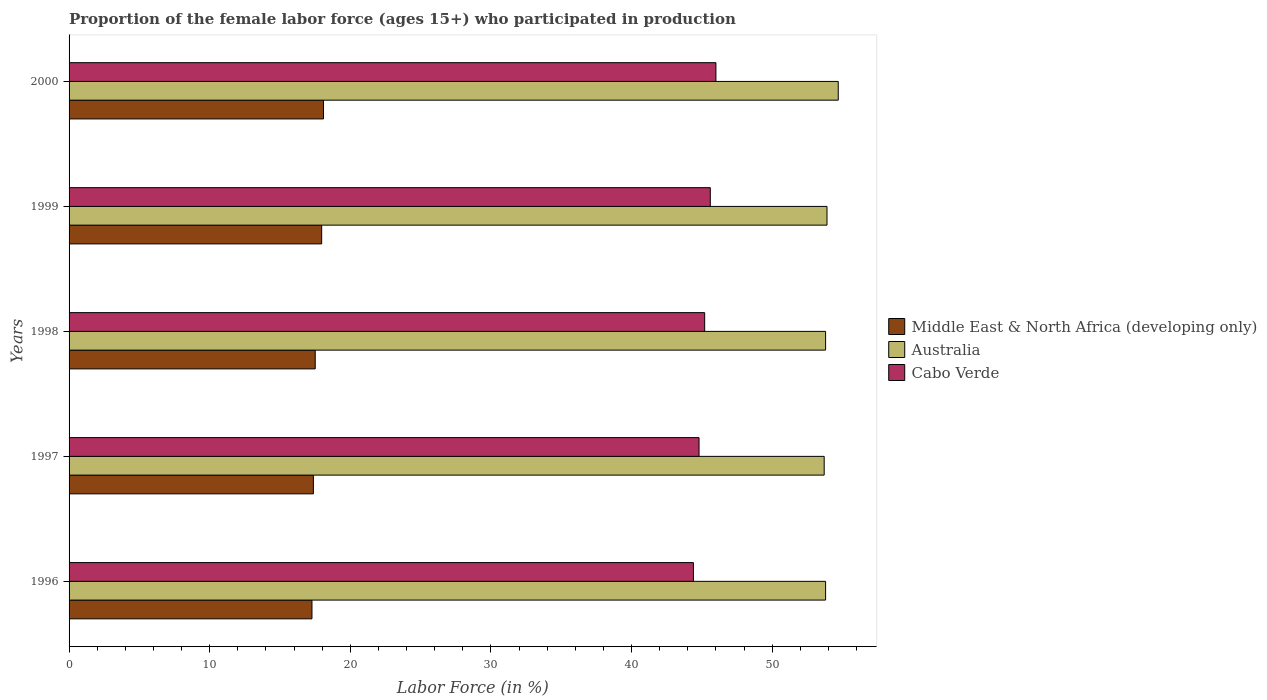How many different coloured bars are there?
Make the answer very short. 3. How many groups of bars are there?
Offer a very short reply. 5. Are the number of bars per tick equal to the number of legend labels?
Provide a succinct answer. Yes. Are the number of bars on each tick of the Y-axis equal?
Your answer should be compact. Yes. How many bars are there on the 5th tick from the top?
Your answer should be compact. 3. What is the label of the 5th group of bars from the top?
Your response must be concise. 1996. What is the proportion of the female labor force who participated in production in Cabo Verde in 1997?
Your response must be concise. 44.8. Across all years, what is the minimum proportion of the female labor force who participated in production in Cabo Verde?
Your answer should be very brief. 44.4. In which year was the proportion of the female labor force who participated in production in Cabo Verde maximum?
Ensure brevity in your answer.  2000. What is the total proportion of the female labor force who participated in production in Middle East & North Africa (developing only) in the graph?
Ensure brevity in your answer.  88.21. What is the difference between the proportion of the female labor force who participated in production in Cabo Verde in 1998 and that in 2000?
Give a very brief answer. -0.8. What is the difference between the proportion of the female labor force who participated in production in Middle East & North Africa (developing only) in 1997 and the proportion of the female labor force who participated in production in Cabo Verde in 1999?
Offer a terse response. -28.23. What is the average proportion of the female labor force who participated in production in Cabo Verde per year?
Offer a terse response. 45.2. In the year 1998, what is the difference between the proportion of the female labor force who participated in production in Middle East & North Africa (developing only) and proportion of the female labor force who participated in production in Cabo Verde?
Provide a short and direct response. -27.7. In how many years, is the proportion of the female labor force who participated in production in Australia greater than 30 %?
Provide a succinct answer. 5. What is the ratio of the proportion of the female labor force who participated in production in Australia in 1997 to that in 2000?
Offer a very short reply. 0.98. Is the difference between the proportion of the female labor force who participated in production in Middle East & North Africa (developing only) in 1998 and 2000 greater than the difference between the proportion of the female labor force who participated in production in Cabo Verde in 1998 and 2000?
Keep it short and to the point. Yes. What is the difference between the highest and the second highest proportion of the female labor force who participated in production in Cabo Verde?
Give a very brief answer. 0.4. What is the difference between the highest and the lowest proportion of the female labor force who participated in production in Middle East & North Africa (developing only)?
Provide a short and direct response. 0.82. In how many years, is the proportion of the female labor force who participated in production in Australia greater than the average proportion of the female labor force who participated in production in Australia taken over all years?
Your response must be concise. 1. What does the 1st bar from the top in 1996 represents?
Keep it short and to the point. Cabo Verde. What does the 3rd bar from the bottom in 1998 represents?
Offer a terse response. Cabo Verde. How many bars are there?
Provide a succinct answer. 15. Are all the bars in the graph horizontal?
Offer a terse response. Yes. What is the difference between two consecutive major ticks on the X-axis?
Give a very brief answer. 10. How many legend labels are there?
Provide a succinct answer. 3. How are the legend labels stacked?
Your answer should be very brief. Vertical. What is the title of the graph?
Make the answer very short. Proportion of the female labor force (ages 15+) who participated in production. Does "Kyrgyz Republic" appear as one of the legend labels in the graph?
Your response must be concise. No. What is the Labor Force (in %) of Middle East & North Africa (developing only) in 1996?
Make the answer very short. 17.27. What is the Labor Force (in %) of Australia in 1996?
Your response must be concise. 53.8. What is the Labor Force (in %) in Cabo Verde in 1996?
Your response must be concise. 44.4. What is the Labor Force (in %) of Middle East & North Africa (developing only) in 1997?
Your response must be concise. 17.37. What is the Labor Force (in %) of Australia in 1997?
Your response must be concise. 53.7. What is the Labor Force (in %) in Cabo Verde in 1997?
Ensure brevity in your answer.  44.8. What is the Labor Force (in %) of Middle East & North Africa (developing only) in 1998?
Give a very brief answer. 17.5. What is the Labor Force (in %) of Australia in 1998?
Ensure brevity in your answer.  53.8. What is the Labor Force (in %) in Cabo Verde in 1998?
Offer a very short reply. 45.2. What is the Labor Force (in %) in Middle East & North Africa (developing only) in 1999?
Ensure brevity in your answer.  17.96. What is the Labor Force (in %) in Australia in 1999?
Your answer should be very brief. 53.9. What is the Labor Force (in %) of Cabo Verde in 1999?
Your answer should be very brief. 45.6. What is the Labor Force (in %) in Middle East & North Africa (developing only) in 2000?
Your answer should be very brief. 18.09. What is the Labor Force (in %) in Australia in 2000?
Provide a short and direct response. 54.7. Across all years, what is the maximum Labor Force (in %) of Middle East & North Africa (developing only)?
Your answer should be compact. 18.09. Across all years, what is the maximum Labor Force (in %) in Australia?
Your answer should be very brief. 54.7. Across all years, what is the minimum Labor Force (in %) of Middle East & North Africa (developing only)?
Ensure brevity in your answer.  17.27. Across all years, what is the minimum Labor Force (in %) of Australia?
Offer a terse response. 53.7. Across all years, what is the minimum Labor Force (in %) in Cabo Verde?
Provide a short and direct response. 44.4. What is the total Labor Force (in %) in Middle East & North Africa (developing only) in the graph?
Provide a succinct answer. 88.21. What is the total Labor Force (in %) of Australia in the graph?
Offer a terse response. 269.9. What is the total Labor Force (in %) of Cabo Verde in the graph?
Provide a succinct answer. 226. What is the difference between the Labor Force (in %) of Middle East & North Africa (developing only) in 1996 and that in 1997?
Make the answer very short. -0.1. What is the difference between the Labor Force (in %) in Middle East & North Africa (developing only) in 1996 and that in 1998?
Ensure brevity in your answer.  -0.23. What is the difference between the Labor Force (in %) in Cabo Verde in 1996 and that in 1998?
Offer a very short reply. -0.8. What is the difference between the Labor Force (in %) of Middle East & North Africa (developing only) in 1996 and that in 1999?
Offer a terse response. -0.69. What is the difference between the Labor Force (in %) of Australia in 1996 and that in 1999?
Keep it short and to the point. -0.1. What is the difference between the Labor Force (in %) in Middle East & North Africa (developing only) in 1996 and that in 2000?
Your response must be concise. -0.82. What is the difference between the Labor Force (in %) of Australia in 1996 and that in 2000?
Provide a succinct answer. -0.9. What is the difference between the Labor Force (in %) of Cabo Verde in 1996 and that in 2000?
Offer a terse response. -1.6. What is the difference between the Labor Force (in %) in Middle East & North Africa (developing only) in 1997 and that in 1998?
Offer a very short reply. -0.13. What is the difference between the Labor Force (in %) of Cabo Verde in 1997 and that in 1998?
Your answer should be compact. -0.4. What is the difference between the Labor Force (in %) of Middle East & North Africa (developing only) in 1997 and that in 1999?
Keep it short and to the point. -0.59. What is the difference between the Labor Force (in %) of Middle East & North Africa (developing only) in 1997 and that in 2000?
Your answer should be compact. -0.72. What is the difference between the Labor Force (in %) of Middle East & North Africa (developing only) in 1998 and that in 1999?
Make the answer very short. -0.46. What is the difference between the Labor Force (in %) of Australia in 1998 and that in 1999?
Your response must be concise. -0.1. What is the difference between the Labor Force (in %) of Middle East & North Africa (developing only) in 1998 and that in 2000?
Make the answer very short. -0.59. What is the difference between the Labor Force (in %) of Australia in 1998 and that in 2000?
Offer a terse response. -0.9. What is the difference between the Labor Force (in %) in Cabo Verde in 1998 and that in 2000?
Provide a short and direct response. -0.8. What is the difference between the Labor Force (in %) in Middle East & North Africa (developing only) in 1999 and that in 2000?
Your answer should be compact. -0.13. What is the difference between the Labor Force (in %) of Cabo Verde in 1999 and that in 2000?
Provide a short and direct response. -0.4. What is the difference between the Labor Force (in %) in Middle East & North Africa (developing only) in 1996 and the Labor Force (in %) in Australia in 1997?
Your response must be concise. -36.43. What is the difference between the Labor Force (in %) in Middle East & North Africa (developing only) in 1996 and the Labor Force (in %) in Cabo Verde in 1997?
Ensure brevity in your answer.  -27.53. What is the difference between the Labor Force (in %) in Australia in 1996 and the Labor Force (in %) in Cabo Verde in 1997?
Give a very brief answer. 9. What is the difference between the Labor Force (in %) of Middle East & North Africa (developing only) in 1996 and the Labor Force (in %) of Australia in 1998?
Provide a succinct answer. -36.53. What is the difference between the Labor Force (in %) in Middle East & North Africa (developing only) in 1996 and the Labor Force (in %) in Cabo Verde in 1998?
Your answer should be very brief. -27.93. What is the difference between the Labor Force (in %) of Middle East & North Africa (developing only) in 1996 and the Labor Force (in %) of Australia in 1999?
Your answer should be very brief. -36.63. What is the difference between the Labor Force (in %) of Middle East & North Africa (developing only) in 1996 and the Labor Force (in %) of Cabo Verde in 1999?
Give a very brief answer. -28.33. What is the difference between the Labor Force (in %) of Australia in 1996 and the Labor Force (in %) of Cabo Verde in 1999?
Provide a succinct answer. 8.2. What is the difference between the Labor Force (in %) in Middle East & North Africa (developing only) in 1996 and the Labor Force (in %) in Australia in 2000?
Give a very brief answer. -37.43. What is the difference between the Labor Force (in %) of Middle East & North Africa (developing only) in 1996 and the Labor Force (in %) of Cabo Verde in 2000?
Your answer should be compact. -28.73. What is the difference between the Labor Force (in %) of Australia in 1996 and the Labor Force (in %) of Cabo Verde in 2000?
Offer a very short reply. 7.8. What is the difference between the Labor Force (in %) of Middle East & North Africa (developing only) in 1997 and the Labor Force (in %) of Australia in 1998?
Your response must be concise. -36.43. What is the difference between the Labor Force (in %) in Middle East & North Africa (developing only) in 1997 and the Labor Force (in %) in Cabo Verde in 1998?
Provide a succinct answer. -27.83. What is the difference between the Labor Force (in %) in Middle East & North Africa (developing only) in 1997 and the Labor Force (in %) in Australia in 1999?
Your response must be concise. -36.53. What is the difference between the Labor Force (in %) of Middle East & North Africa (developing only) in 1997 and the Labor Force (in %) of Cabo Verde in 1999?
Your answer should be very brief. -28.23. What is the difference between the Labor Force (in %) in Australia in 1997 and the Labor Force (in %) in Cabo Verde in 1999?
Your response must be concise. 8.1. What is the difference between the Labor Force (in %) of Middle East & North Africa (developing only) in 1997 and the Labor Force (in %) of Australia in 2000?
Provide a short and direct response. -37.33. What is the difference between the Labor Force (in %) of Middle East & North Africa (developing only) in 1997 and the Labor Force (in %) of Cabo Verde in 2000?
Make the answer very short. -28.63. What is the difference between the Labor Force (in %) of Australia in 1997 and the Labor Force (in %) of Cabo Verde in 2000?
Your answer should be compact. 7.7. What is the difference between the Labor Force (in %) in Middle East & North Africa (developing only) in 1998 and the Labor Force (in %) in Australia in 1999?
Provide a short and direct response. -36.4. What is the difference between the Labor Force (in %) in Middle East & North Africa (developing only) in 1998 and the Labor Force (in %) in Cabo Verde in 1999?
Ensure brevity in your answer.  -28.1. What is the difference between the Labor Force (in %) of Middle East & North Africa (developing only) in 1998 and the Labor Force (in %) of Australia in 2000?
Provide a short and direct response. -37.2. What is the difference between the Labor Force (in %) in Middle East & North Africa (developing only) in 1998 and the Labor Force (in %) in Cabo Verde in 2000?
Keep it short and to the point. -28.5. What is the difference between the Labor Force (in %) of Middle East & North Africa (developing only) in 1999 and the Labor Force (in %) of Australia in 2000?
Give a very brief answer. -36.74. What is the difference between the Labor Force (in %) of Middle East & North Africa (developing only) in 1999 and the Labor Force (in %) of Cabo Verde in 2000?
Your response must be concise. -28.04. What is the difference between the Labor Force (in %) of Australia in 1999 and the Labor Force (in %) of Cabo Verde in 2000?
Your answer should be very brief. 7.9. What is the average Labor Force (in %) of Middle East & North Africa (developing only) per year?
Give a very brief answer. 17.64. What is the average Labor Force (in %) of Australia per year?
Your answer should be very brief. 53.98. What is the average Labor Force (in %) in Cabo Verde per year?
Make the answer very short. 45.2. In the year 1996, what is the difference between the Labor Force (in %) of Middle East & North Africa (developing only) and Labor Force (in %) of Australia?
Give a very brief answer. -36.53. In the year 1996, what is the difference between the Labor Force (in %) of Middle East & North Africa (developing only) and Labor Force (in %) of Cabo Verde?
Make the answer very short. -27.13. In the year 1996, what is the difference between the Labor Force (in %) in Australia and Labor Force (in %) in Cabo Verde?
Your answer should be compact. 9.4. In the year 1997, what is the difference between the Labor Force (in %) in Middle East & North Africa (developing only) and Labor Force (in %) in Australia?
Provide a short and direct response. -36.33. In the year 1997, what is the difference between the Labor Force (in %) in Middle East & North Africa (developing only) and Labor Force (in %) in Cabo Verde?
Provide a short and direct response. -27.43. In the year 1998, what is the difference between the Labor Force (in %) in Middle East & North Africa (developing only) and Labor Force (in %) in Australia?
Your answer should be very brief. -36.3. In the year 1998, what is the difference between the Labor Force (in %) in Middle East & North Africa (developing only) and Labor Force (in %) in Cabo Verde?
Make the answer very short. -27.7. In the year 1999, what is the difference between the Labor Force (in %) of Middle East & North Africa (developing only) and Labor Force (in %) of Australia?
Give a very brief answer. -35.94. In the year 1999, what is the difference between the Labor Force (in %) of Middle East & North Africa (developing only) and Labor Force (in %) of Cabo Verde?
Provide a succinct answer. -27.64. In the year 2000, what is the difference between the Labor Force (in %) of Middle East & North Africa (developing only) and Labor Force (in %) of Australia?
Ensure brevity in your answer.  -36.61. In the year 2000, what is the difference between the Labor Force (in %) of Middle East & North Africa (developing only) and Labor Force (in %) of Cabo Verde?
Provide a short and direct response. -27.91. In the year 2000, what is the difference between the Labor Force (in %) of Australia and Labor Force (in %) of Cabo Verde?
Offer a terse response. 8.7. What is the ratio of the Labor Force (in %) in Middle East & North Africa (developing only) in 1996 to that in 1997?
Offer a very short reply. 0.99. What is the ratio of the Labor Force (in %) of Cabo Verde in 1996 to that in 1997?
Provide a succinct answer. 0.99. What is the ratio of the Labor Force (in %) in Middle East & North Africa (developing only) in 1996 to that in 1998?
Your response must be concise. 0.99. What is the ratio of the Labor Force (in %) in Australia in 1996 to that in 1998?
Give a very brief answer. 1. What is the ratio of the Labor Force (in %) in Cabo Verde in 1996 to that in 1998?
Offer a terse response. 0.98. What is the ratio of the Labor Force (in %) in Middle East & North Africa (developing only) in 1996 to that in 1999?
Keep it short and to the point. 0.96. What is the ratio of the Labor Force (in %) of Australia in 1996 to that in 1999?
Provide a succinct answer. 1. What is the ratio of the Labor Force (in %) in Cabo Verde in 1996 to that in 1999?
Ensure brevity in your answer.  0.97. What is the ratio of the Labor Force (in %) in Middle East & North Africa (developing only) in 1996 to that in 2000?
Make the answer very short. 0.95. What is the ratio of the Labor Force (in %) in Australia in 1996 to that in 2000?
Provide a succinct answer. 0.98. What is the ratio of the Labor Force (in %) in Cabo Verde in 1996 to that in 2000?
Provide a succinct answer. 0.97. What is the ratio of the Labor Force (in %) of Australia in 1997 to that in 1998?
Offer a very short reply. 1. What is the ratio of the Labor Force (in %) in Middle East & North Africa (developing only) in 1997 to that in 1999?
Provide a succinct answer. 0.97. What is the ratio of the Labor Force (in %) in Australia in 1997 to that in 1999?
Your response must be concise. 1. What is the ratio of the Labor Force (in %) of Cabo Verde in 1997 to that in 1999?
Ensure brevity in your answer.  0.98. What is the ratio of the Labor Force (in %) in Middle East & North Africa (developing only) in 1997 to that in 2000?
Offer a very short reply. 0.96. What is the ratio of the Labor Force (in %) in Australia in 1997 to that in 2000?
Provide a short and direct response. 0.98. What is the ratio of the Labor Force (in %) of Cabo Verde in 1997 to that in 2000?
Keep it short and to the point. 0.97. What is the ratio of the Labor Force (in %) in Middle East & North Africa (developing only) in 1998 to that in 1999?
Ensure brevity in your answer.  0.97. What is the ratio of the Labor Force (in %) in Australia in 1998 to that in 1999?
Provide a succinct answer. 1. What is the ratio of the Labor Force (in %) in Middle East & North Africa (developing only) in 1998 to that in 2000?
Ensure brevity in your answer.  0.97. What is the ratio of the Labor Force (in %) in Australia in 1998 to that in 2000?
Keep it short and to the point. 0.98. What is the ratio of the Labor Force (in %) in Cabo Verde in 1998 to that in 2000?
Your answer should be very brief. 0.98. What is the ratio of the Labor Force (in %) of Middle East & North Africa (developing only) in 1999 to that in 2000?
Give a very brief answer. 0.99. What is the ratio of the Labor Force (in %) of Australia in 1999 to that in 2000?
Offer a terse response. 0.99. What is the difference between the highest and the second highest Labor Force (in %) in Middle East & North Africa (developing only)?
Provide a succinct answer. 0.13. What is the difference between the highest and the second highest Labor Force (in %) of Australia?
Offer a very short reply. 0.8. What is the difference between the highest and the second highest Labor Force (in %) in Cabo Verde?
Make the answer very short. 0.4. What is the difference between the highest and the lowest Labor Force (in %) in Middle East & North Africa (developing only)?
Keep it short and to the point. 0.82. What is the difference between the highest and the lowest Labor Force (in %) of Australia?
Offer a very short reply. 1. What is the difference between the highest and the lowest Labor Force (in %) in Cabo Verde?
Ensure brevity in your answer.  1.6. 